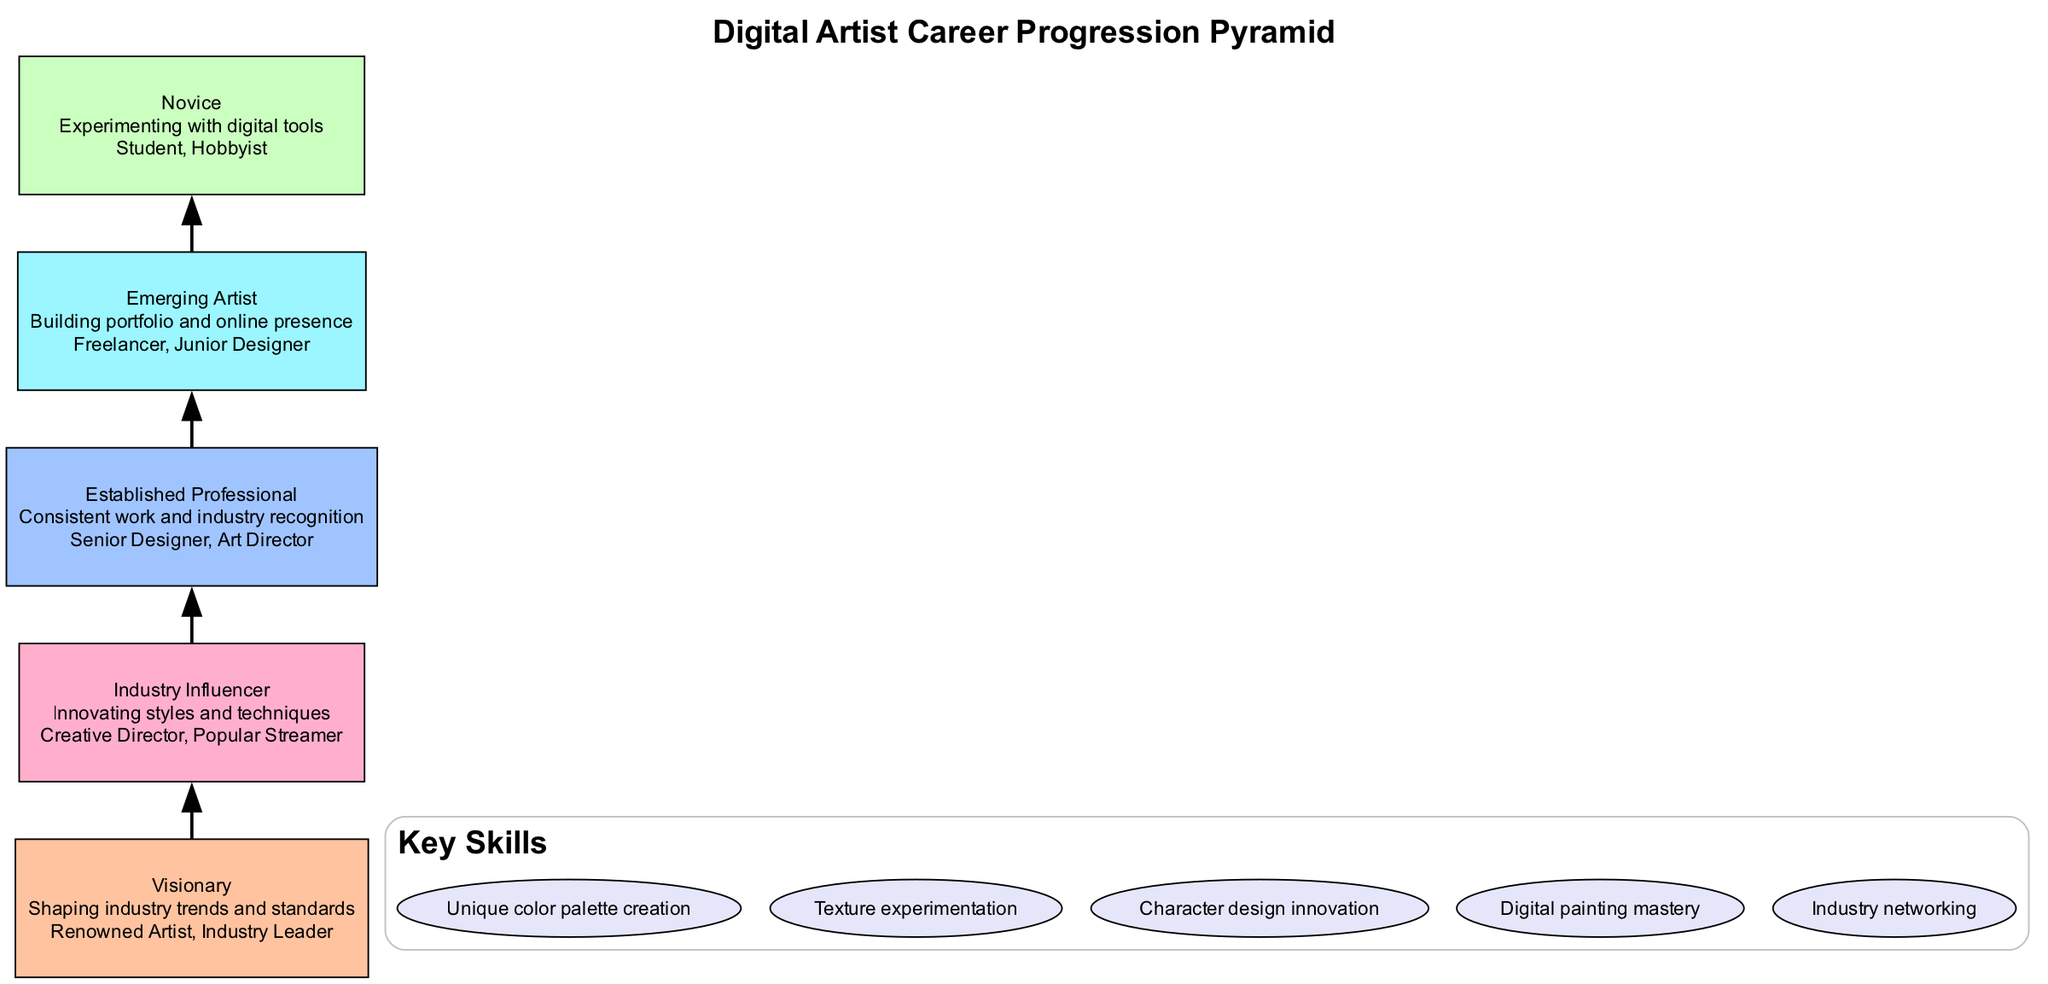What is the highest level in the pyramid? The highest level of the pyramid can be identified as the topmost box which describes 'Visionary'. This term appears as the title for that level within the diagram structure.
Answer: Visionary How many levels are in the career progression pyramid? The number of levels can be found by counting the distinct sections in the pyramid. In this case, there are five unique levels presented vertically.
Answer: 5 What is the description of the 'Established Professional' level? To find the description, we look specifically for the box labeled 'Established Professional' in the pyramid. The description follows this label in the diagram.
Answer: Consistent work and industry recognition Which level is associated with the role 'Creative Director'? This role can be linked to a specific level in the pyramid, and it is found in the section that lists 'Industry Influencer' as an example of that level.
Answer: Industry Influencer What key skill is related to creating unique color palettes? The relevant skill can be located in the skills section of the diagram. This particular skill is explicitly listed amongst the key skills provided in a separate section of the diagram.
Answer: Unique color palette creation What is the relationship between 'Emerging Artist' and 'Established Professional'? The relationship can be understood through the directional connection indicated by the arrows in the diagram, where 'Emerging Artist' leads to 'Established Professional' as a stage in progression.
Answer: Progression How does one progress from 'Novice' to 'Emerging Artist'? The progression can be understood as a step in a hierarchy that connects 'Novice' directly to 'Emerging Artist', indicating that one must first gain experience to advance to this next level.
Answer: Experience How is 'Industry Influencer' described in the pyramid? To find the description, we need to refer to the section labeled 'Industry Influencer'. The description underneath gives the necessary context about what this level entails.
Answer: Innovating styles and techniques What examples are given for the 'Visionary' level? We identify examples by looking for the section connected to 'Visionary' in the pyramid, where its associated roles are listed. The specific names provided show what characterizes this level.
Answer: Renowned Artist, Industry Leader 